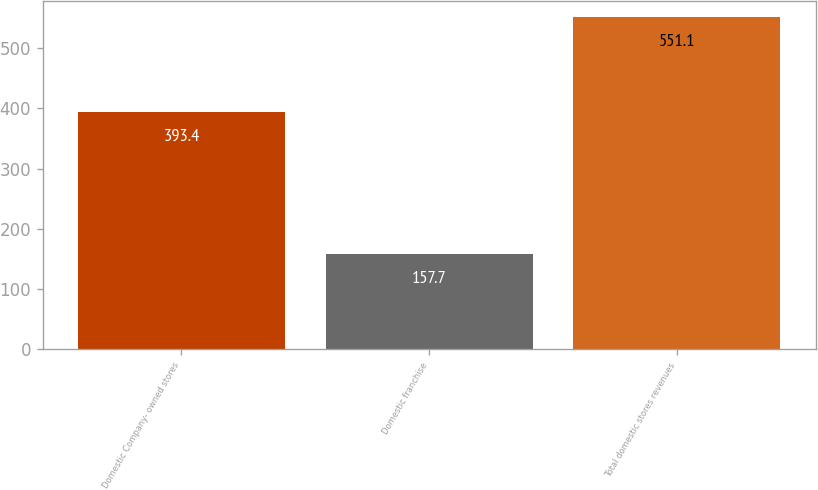<chart> <loc_0><loc_0><loc_500><loc_500><bar_chart><fcel>Domestic Company- owned stores<fcel>Domestic franchise<fcel>Total domestic stores revenues<nl><fcel>393.4<fcel>157.7<fcel>551.1<nl></chart> 